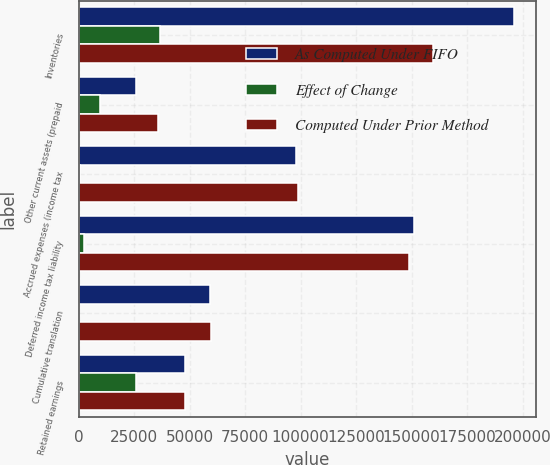Convert chart to OTSL. <chart><loc_0><loc_0><loc_500><loc_500><stacked_bar_chart><ecel><fcel>Inventories<fcel>Other current assets (prepaid<fcel>Accrued expenses (income tax<fcel>Deferred income tax liability<fcel>Cumulative translation<fcel>Retained earnings<nl><fcel>As Computed Under FIFO<fcel>196162<fcel>25876<fcel>98116<fcel>151158<fcel>59137<fcel>47918<nl><fcel>Effect of Change<fcel>36699<fcel>9669<fcel>614<fcel>2352<fcel>262<fcel>25623<nl><fcel>Computed Under Prior Method<fcel>159463<fcel>35545<fcel>98730<fcel>148806<fcel>59399<fcel>47918<nl></chart> 